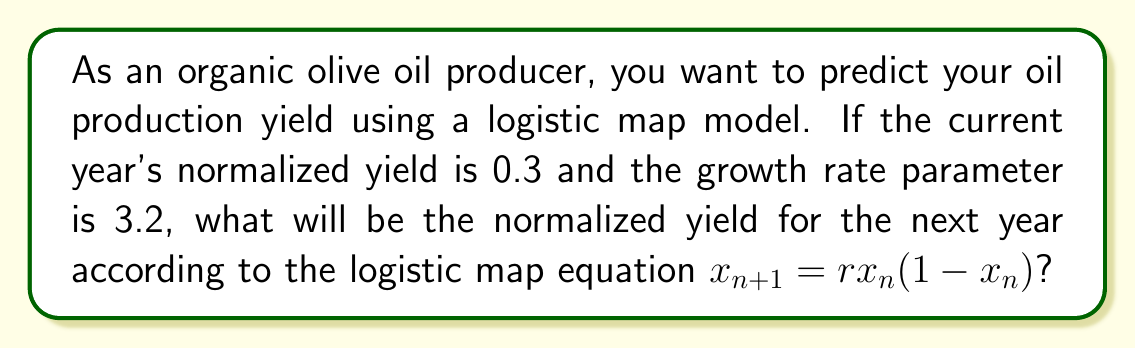Teach me how to tackle this problem. To solve this problem, we'll use the logistic map equation:

$$x_{n+1} = rx_n(1-x_n)$$

Where:
- $x_n$ is the current year's normalized yield (0.3)
- $r$ is the growth rate parameter (3.2)
- $x_{n+1}$ is the next year's normalized yield (what we're solving for)

Let's substitute the values into the equation:

$$x_{n+1} = 3.2 \cdot 0.3 \cdot (1-0.3)$$

Now, let's solve step by step:

1. Calculate $(1-0.3)$:
   $1 - 0.3 = 0.7$

2. Multiply $3.2 \cdot 0.3 \cdot 0.7$:
   $3.2 \cdot 0.3 = 0.96$
   $0.96 \cdot 0.7 = 0.672$

Therefore, the normalized yield for the next year will be 0.672.
Answer: 0.672 